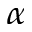<formula> <loc_0><loc_0><loc_500><loc_500>_ { \alpha }</formula> 